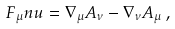Convert formula to latex. <formula><loc_0><loc_0><loc_500><loc_500>F _ { \mu } n u = \nabla _ { \mu } A _ { \nu } - \nabla _ { \nu } A _ { \mu } \, ,</formula> 